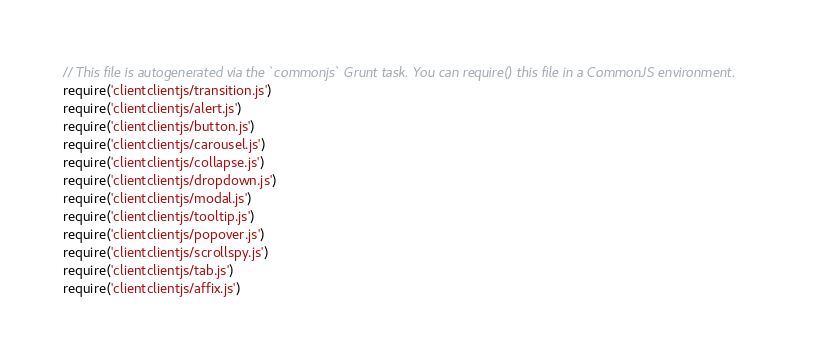Convert code to text. <code><loc_0><loc_0><loc_500><loc_500><_JavaScript_>// This file is autogenerated via the `commonjs` Grunt task. You can require() this file in a CommonJS environment.
require('clientclientjs/transition.js')
require('clientclientjs/alert.js')
require('clientclientjs/button.js')
require('clientclientjs/carousel.js')
require('clientclientjs/collapse.js')
require('clientclientjs/dropdown.js')
require('clientclientjs/modal.js')
require('clientclientjs/tooltip.js')
require('clientclientjs/popover.js')
require('clientclientjs/scrollspy.js')
require('clientclientjs/tab.js')
require('clientclientjs/affix.js')</code> 